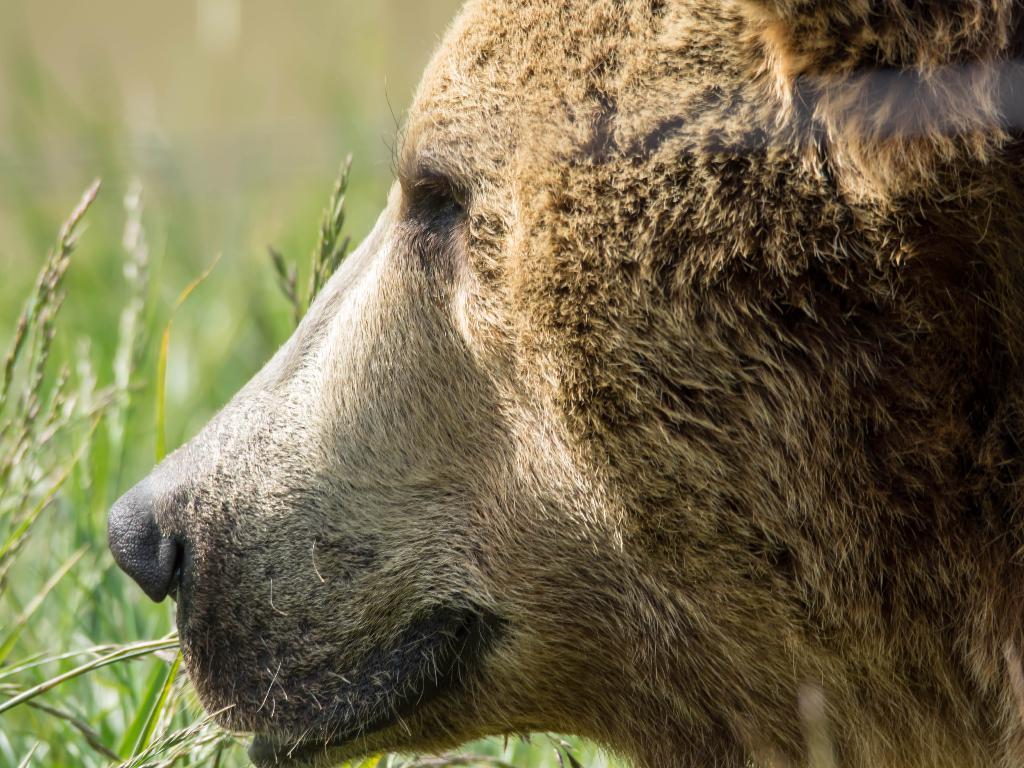How would you summarize this image in a sentence or two? In this image there is a side view of the bears face. In the background there is grass. 